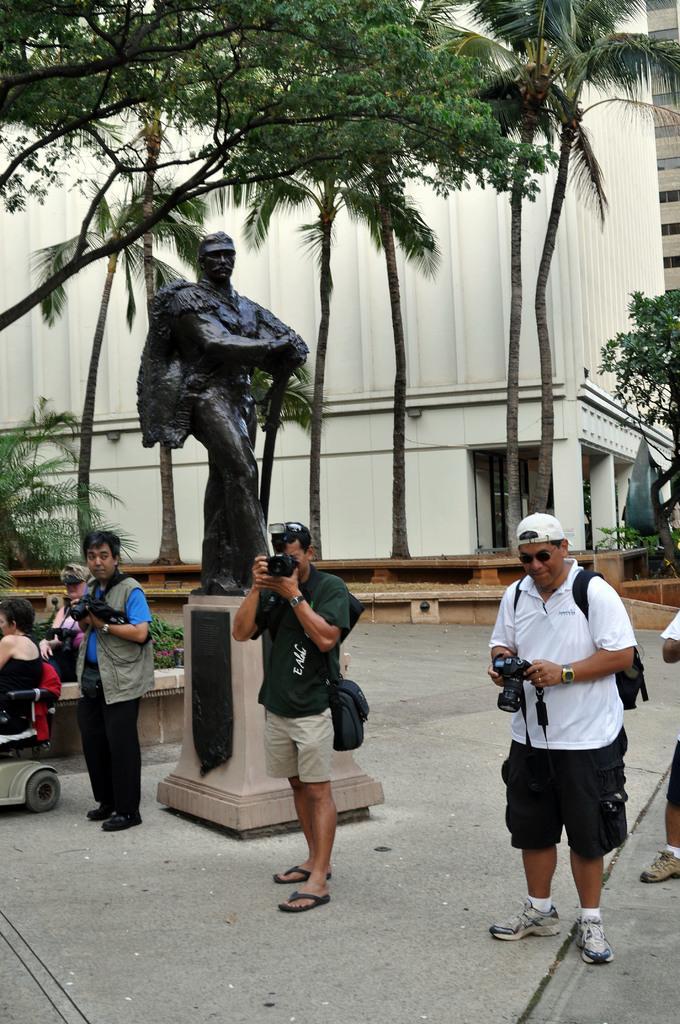In one or two sentences, can you explain what this image depicts? In this image there are three people standing and holding a camera in their hand are clicking pictures, behind them there are two other people sitting in wheelchairs and there is a statue, in the background of the image there are trees and buildings. 